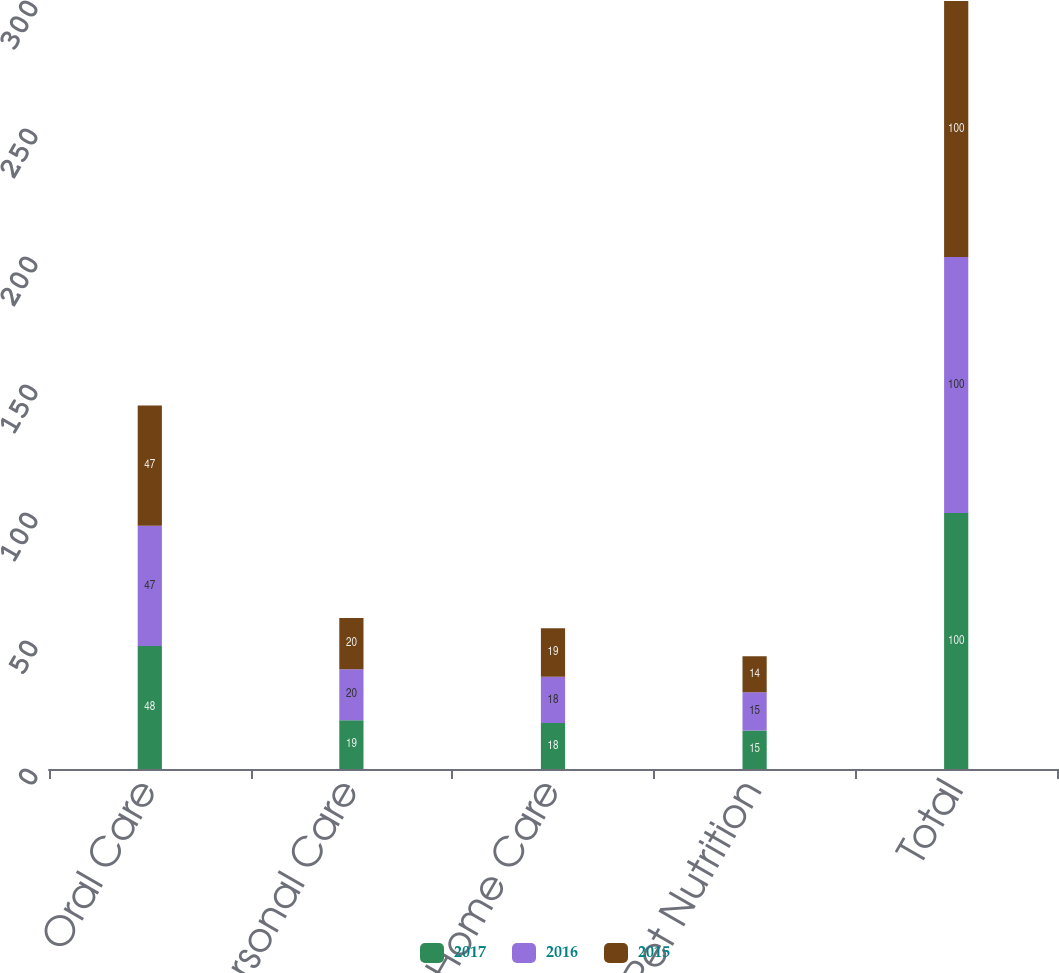<chart> <loc_0><loc_0><loc_500><loc_500><stacked_bar_chart><ecel><fcel>Oral Care<fcel>Personal Care<fcel>Home Care<fcel>Pet Nutrition<fcel>Total<nl><fcel>2017<fcel>48<fcel>19<fcel>18<fcel>15<fcel>100<nl><fcel>2016<fcel>47<fcel>20<fcel>18<fcel>15<fcel>100<nl><fcel>2015<fcel>47<fcel>20<fcel>19<fcel>14<fcel>100<nl></chart> 